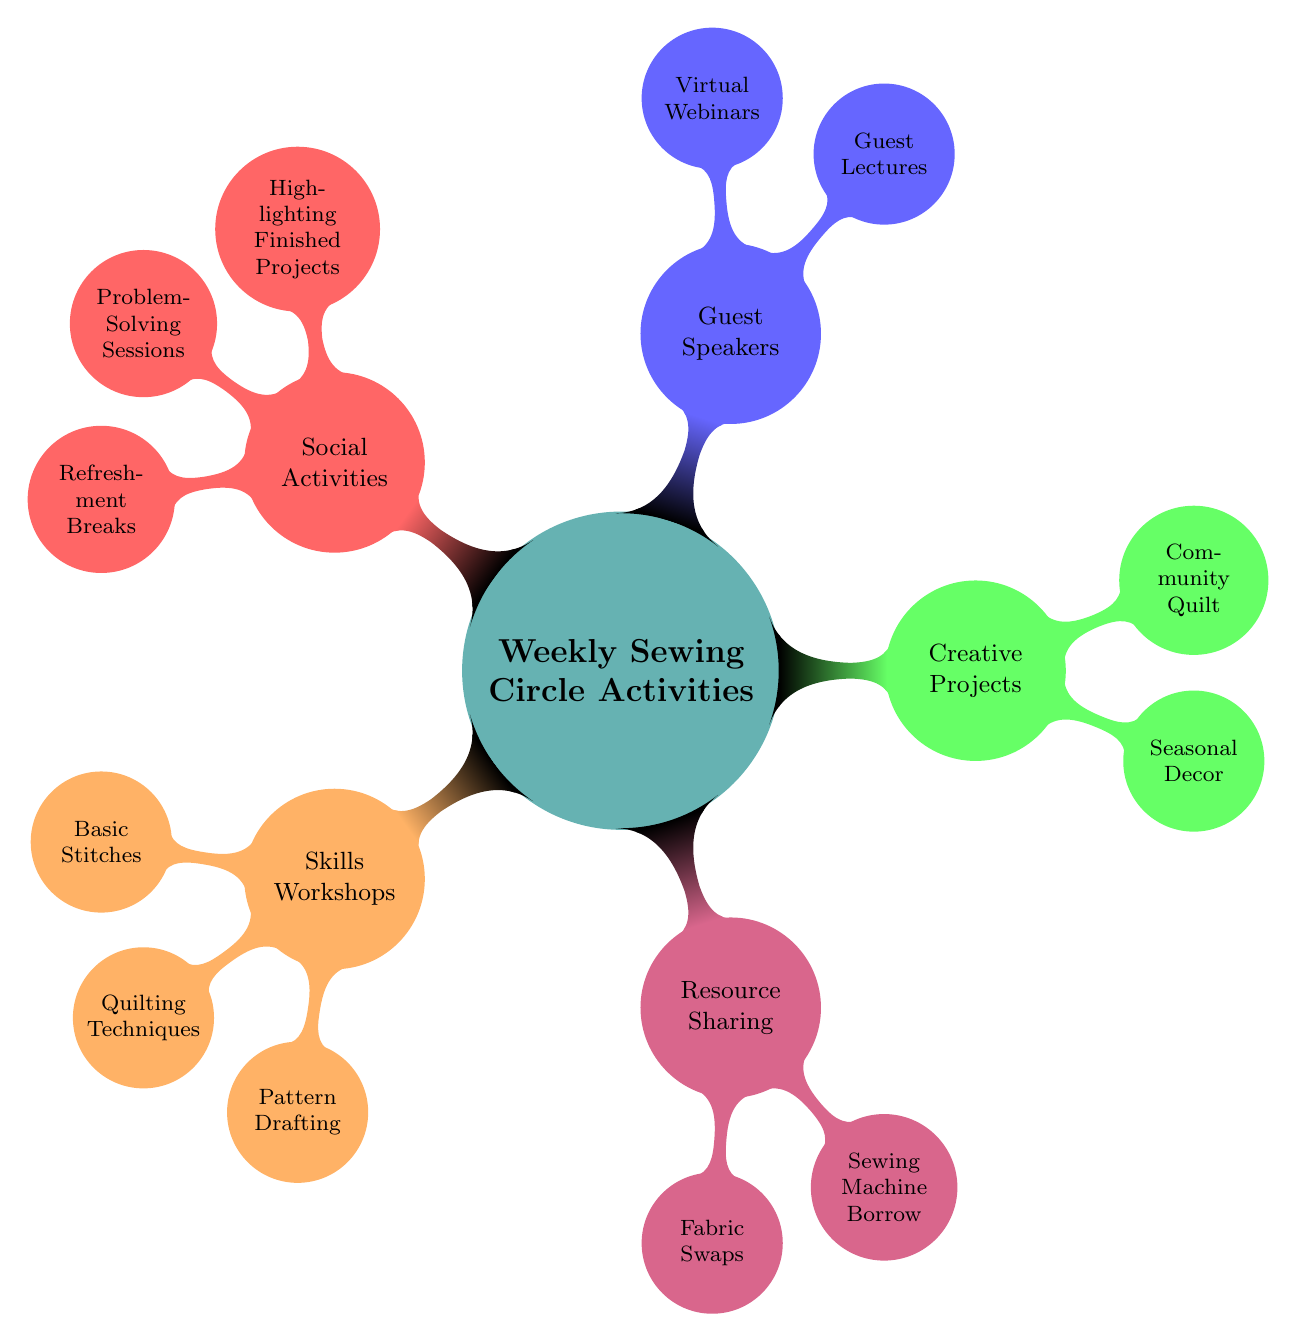What are the main categories of activities in the sewing circle? The diagram shows five main categories branching from the central node "Weekly Sewing Circle Activities": Skills Workshops, Resource Sharing, Creative Projects, Guest Speakers, and Social Activities.
Answer: Skills Workshops, Resource Sharing, Creative Projects, Guest Speakers, Social Activities How many activities are listed under "Skills Workshops"? Under the "Skills Workshops" node, there are three activities listed: Basic Stitches, Quilting Techniques, and Pattern Drafting. Counting these nodes gives a total of three.
Answer: 3 What type of resource sharing involves exchanging material? The diagram indicates "Fabric Swaps" under the "Resource Sharing" category, highlighting that this is the specific activity focused on exchanging materials.
Answer: Fabric Swaps Which guest speaker activity is conducted virtually? The "Virtual Webinars" activity is noted under the "Guest Speakers" category, which specifies that this activity is conducted in a virtual format.
Answer: Virtual Webinars What is one type of creative project mentioned in the diagram? The diagram provides two examples of creative projects: "Seasonal Decor" and "Community Quilt". Any of these could serve as potential answers, but "Seasonal Decor" is a specific example mentioned.
Answer: Seasonal Decor What is the purpose of the "Show and Tell" activity? The diagram describes the "Show and Tell" activity under "Social Activities," which specifically highlights finished projects, demonstrating that its purpose is to showcase and celebrate completed work.
Answer: Highlighting Finished Projects Which activity involves design professionals? The "Guest Lectures" node under "Guest Speakers" specifies that this activity involves local designers, illustrating its connection to professional design expertise.
Answer: Guest Lectures How are "Collaborative Projects" categorized? Collaborative Projects are classified under the "Creative Projects" node. The diagram clearly depicts this relationship by showing that "Collaborative Projects" is a sub-node of "Creative Projects."
Answer: Creative Projects 